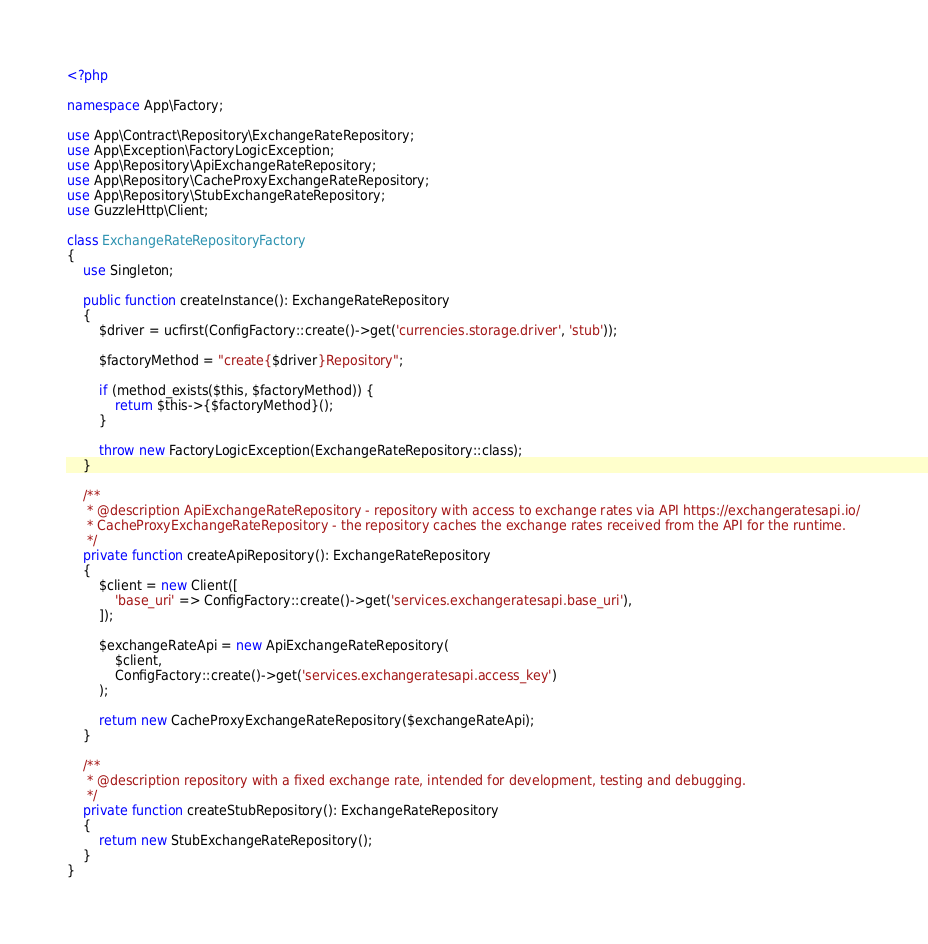<code> <loc_0><loc_0><loc_500><loc_500><_PHP_><?php

namespace App\Factory;

use App\Contract\Repository\ExchangeRateRepository;
use App\Exception\FactoryLogicException;
use App\Repository\ApiExchangeRateRepository;
use App\Repository\CacheProxyExchangeRateRepository;
use App\Repository\StubExchangeRateRepository;
use GuzzleHttp\Client;

class ExchangeRateRepositoryFactory
{
    use Singleton;

    public function createInstance(): ExchangeRateRepository
    {
        $driver = ucfirst(ConfigFactory::create()->get('currencies.storage.driver', 'stub'));

        $factoryMethod = "create{$driver}Repository";

        if (method_exists($this, $factoryMethod)) {
            return $this->{$factoryMethod}();
        }

        throw new FactoryLogicException(ExchangeRateRepository::class);
    }

    /**
     * @description ApiExchangeRateRepository - repository with access to exchange rates via API https://exchangeratesapi.io/
     * CacheProxyExchangeRateRepository - the repository caches the exchange rates received from the API for the runtime.
     */
    private function createApiRepository(): ExchangeRateRepository
    {
        $client = new Client([
            'base_uri' => ConfigFactory::create()->get('services.exchangeratesapi.base_uri'),
        ]);

        $exchangeRateApi = new ApiExchangeRateRepository(
            $client,
            ConfigFactory::create()->get('services.exchangeratesapi.access_key')
        );

        return new CacheProxyExchangeRateRepository($exchangeRateApi);
    }

    /**
     * @description repository with a fixed exchange rate, intended for development, testing and debugging.
     */
    private function createStubRepository(): ExchangeRateRepository
    {
        return new StubExchangeRateRepository();
    }
}
</code> 